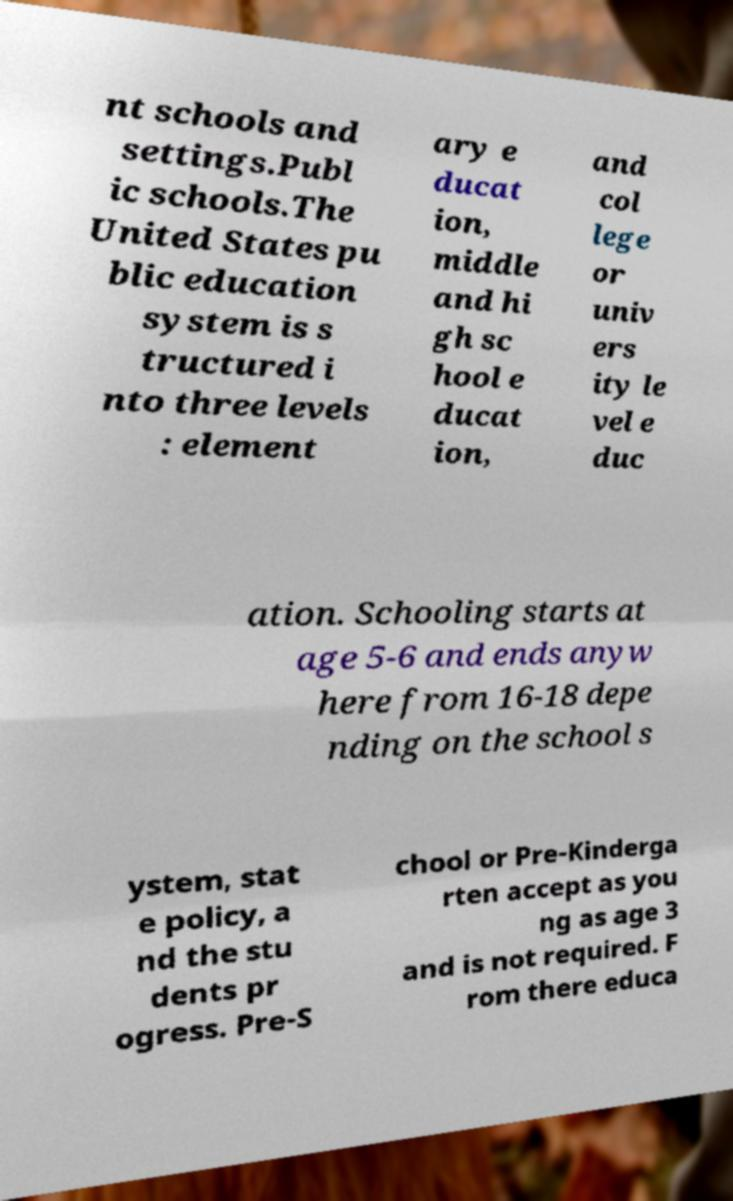I need the written content from this picture converted into text. Can you do that? nt schools and settings.Publ ic schools.The United States pu blic education system is s tructured i nto three levels : element ary e ducat ion, middle and hi gh sc hool e ducat ion, and col lege or univ ers ity le vel e duc ation. Schooling starts at age 5-6 and ends anyw here from 16-18 depe nding on the school s ystem, stat e policy, a nd the stu dents pr ogress. Pre-S chool or Pre-Kinderga rten accept as you ng as age 3 and is not required. F rom there educa 